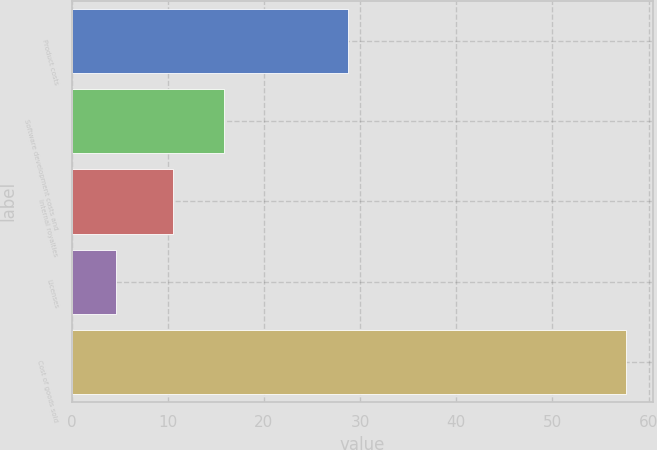<chart> <loc_0><loc_0><loc_500><loc_500><bar_chart><fcel>Product costs<fcel>Software development costs and<fcel>Internal royalties<fcel>Licenses<fcel>Cost of goods sold<nl><fcel>28.7<fcel>15.8<fcel>10.5<fcel>4.6<fcel>57.6<nl></chart> 